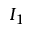Convert formula to latex. <formula><loc_0><loc_0><loc_500><loc_500>I _ { 1 }</formula> 